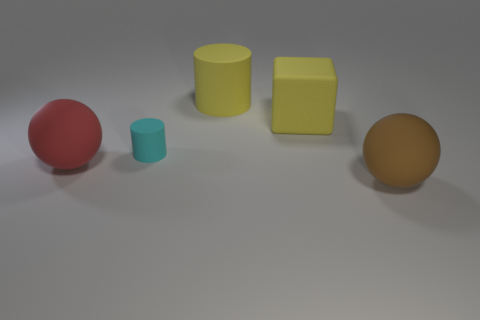Add 2 tiny yellow objects. How many objects exist? 7 Subtract all balls. How many objects are left? 3 Subtract 0 purple spheres. How many objects are left? 5 Subtract all cyan matte cylinders. Subtract all big brown spheres. How many objects are left? 3 Add 3 cyan rubber objects. How many cyan rubber objects are left? 4 Add 5 large yellow things. How many large yellow things exist? 7 